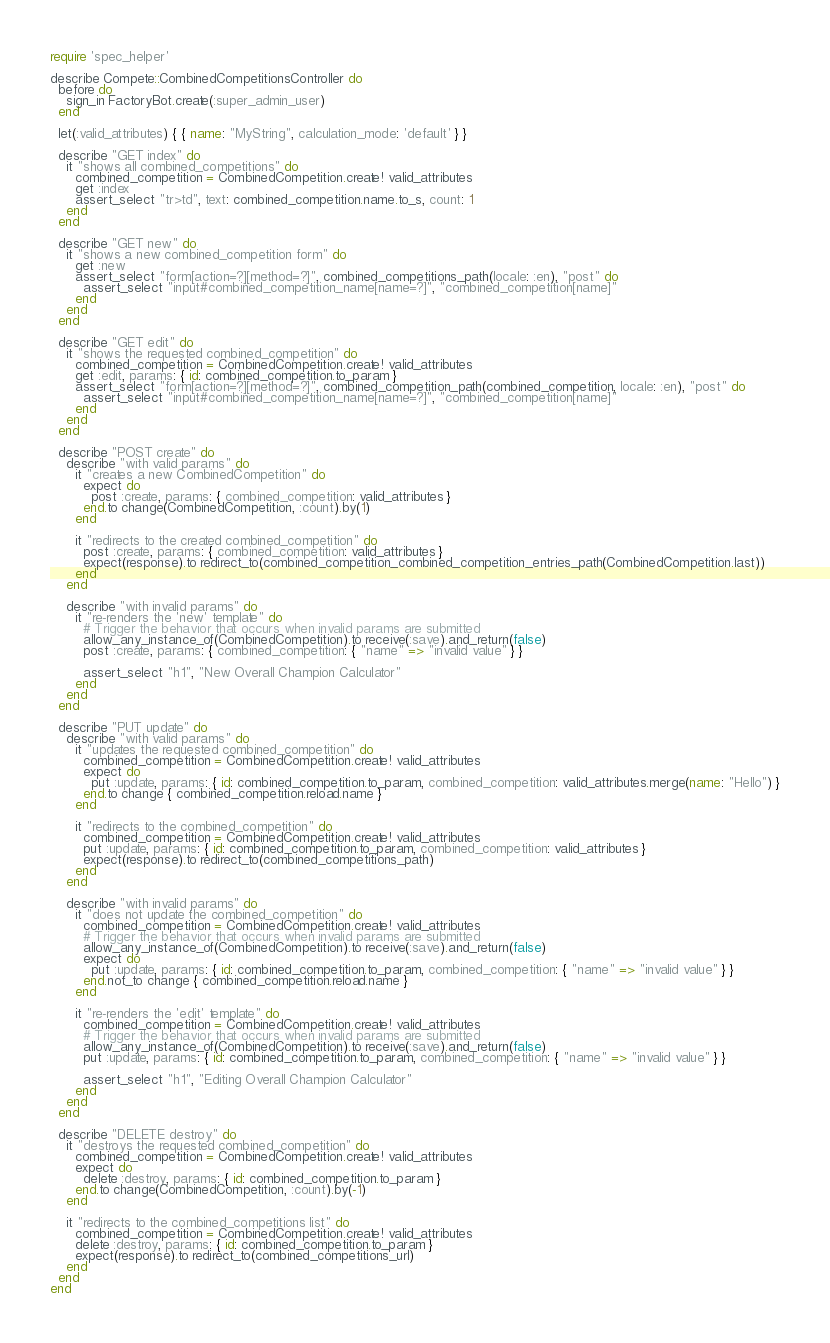Convert code to text. <code><loc_0><loc_0><loc_500><loc_500><_Ruby_>require 'spec_helper'

describe Compete::CombinedCompetitionsController do
  before do
    sign_in FactoryBot.create(:super_admin_user)
  end

  let(:valid_attributes) { { name: "MyString", calculation_mode: 'default' } }

  describe "GET index" do
    it "shows all combined_competitions" do
      combined_competition = CombinedCompetition.create! valid_attributes
      get :index
      assert_select "tr>td", text: combined_competition.name.to_s, count: 1
    end
  end

  describe "GET new" do
    it "shows a new combined_competition form" do
      get :new
      assert_select "form[action=?][method=?]", combined_competitions_path(locale: :en), "post" do
        assert_select "input#combined_competition_name[name=?]", "combined_competition[name]"
      end
    end
  end

  describe "GET edit" do
    it "shows the requested combined_competition" do
      combined_competition = CombinedCompetition.create! valid_attributes
      get :edit, params: { id: combined_competition.to_param }
      assert_select "form[action=?][method=?]", combined_competition_path(combined_competition, locale: :en), "post" do
        assert_select "input#combined_competition_name[name=?]", "combined_competition[name]"
      end
    end
  end

  describe "POST create" do
    describe "with valid params" do
      it "creates a new CombinedCompetition" do
        expect do
          post :create, params: { combined_competition: valid_attributes }
        end.to change(CombinedCompetition, :count).by(1)
      end

      it "redirects to the created combined_competition" do
        post :create, params: { combined_competition: valid_attributes }
        expect(response).to redirect_to(combined_competition_combined_competition_entries_path(CombinedCompetition.last))
      end
    end

    describe "with invalid params" do
      it "re-renders the 'new' template" do
        # Trigger the behavior that occurs when invalid params are submitted
        allow_any_instance_of(CombinedCompetition).to receive(:save).and_return(false)
        post :create, params: { combined_competition: { "name" => "invalid value" } }

        assert_select "h1", "New Overall Champion Calculator"
      end
    end
  end

  describe "PUT update" do
    describe "with valid params" do
      it "updates the requested combined_competition" do
        combined_competition = CombinedCompetition.create! valid_attributes
        expect do
          put :update, params: { id: combined_competition.to_param, combined_competition: valid_attributes.merge(name: "Hello") }
        end.to change { combined_competition.reload.name }
      end

      it "redirects to the combined_competition" do
        combined_competition = CombinedCompetition.create! valid_attributes
        put :update, params: { id: combined_competition.to_param, combined_competition: valid_attributes }
        expect(response).to redirect_to(combined_competitions_path)
      end
    end

    describe "with invalid params" do
      it "does not update the combined_competition" do
        combined_competition = CombinedCompetition.create! valid_attributes
        # Trigger the behavior that occurs when invalid params are submitted
        allow_any_instance_of(CombinedCompetition).to receive(:save).and_return(false)
        expect do
          put :update, params: { id: combined_competition.to_param, combined_competition: { "name" => "invalid value" } }
        end.not_to change { combined_competition.reload.name }
      end

      it "re-renders the 'edit' template" do
        combined_competition = CombinedCompetition.create! valid_attributes
        # Trigger the behavior that occurs when invalid params are submitted
        allow_any_instance_of(CombinedCompetition).to receive(:save).and_return(false)
        put :update, params: { id: combined_competition.to_param, combined_competition: { "name" => "invalid value" } }

        assert_select "h1", "Editing Overall Champion Calculator"
      end
    end
  end

  describe "DELETE destroy" do
    it "destroys the requested combined_competition" do
      combined_competition = CombinedCompetition.create! valid_attributes
      expect do
        delete :destroy, params: { id: combined_competition.to_param }
      end.to change(CombinedCompetition, :count).by(-1)
    end

    it "redirects to the combined_competitions list" do
      combined_competition = CombinedCompetition.create! valid_attributes
      delete :destroy, params: { id: combined_competition.to_param }
      expect(response).to redirect_to(combined_competitions_url)
    end
  end
end
</code> 